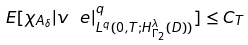Convert formula to latex. <formula><loc_0><loc_0><loc_500><loc_500>E [ \chi _ { A _ { \delta } } | v _ { \ } e | ^ { q } _ { L ^ { q } ( 0 , T ; H ^ { \lambda } _ { \Gamma _ { 2 } } ( D ) ) } ] \leq C _ { T }</formula> 